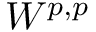<formula> <loc_0><loc_0><loc_500><loc_500>W ^ { p , p }</formula> 